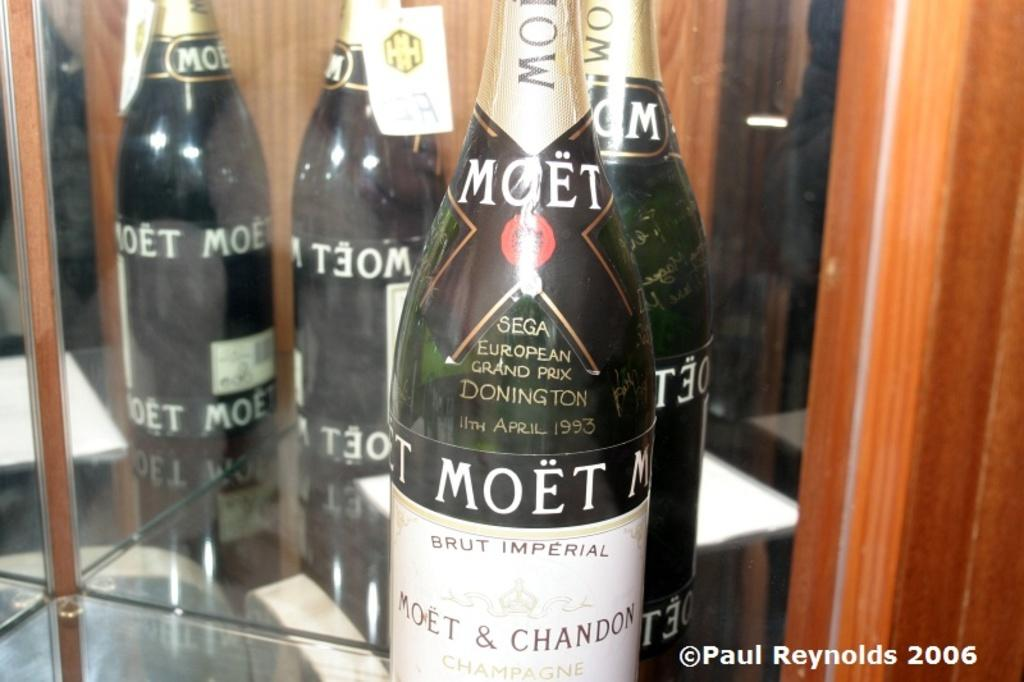<image>
Give a short and clear explanation of the subsequent image. the word Moet that is on a wine bottle 